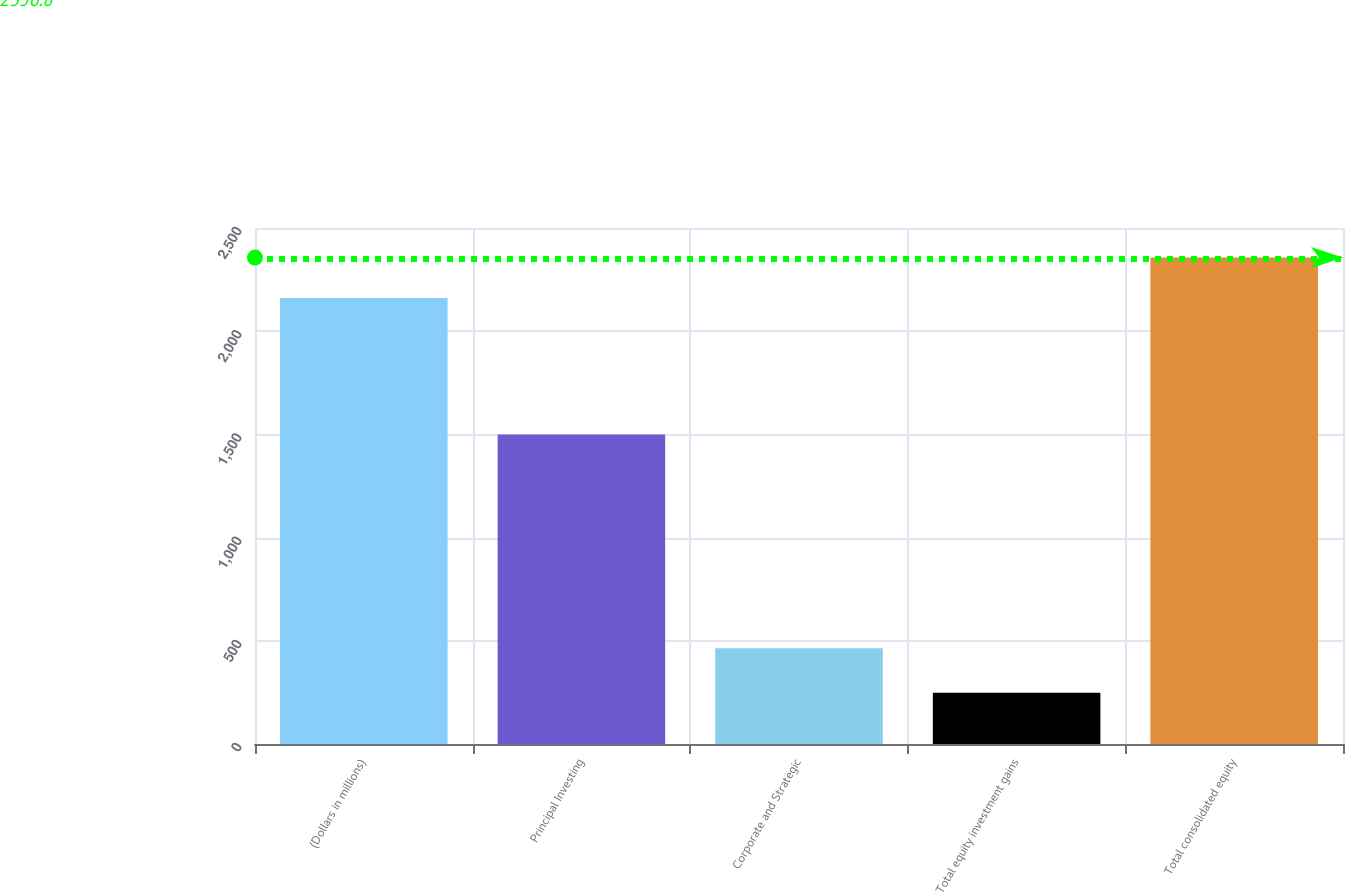Convert chart. <chart><loc_0><loc_0><loc_500><loc_500><bar_chart><fcel>(Dollars in millions)<fcel>Principal Investing<fcel>Corporate and Strategic<fcel>Total equity investment gains<fcel>Total consolidated equity<nl><fcel>2160.4<fcel>1500<fcel>464<fcel>248<fcel>2356.8<nl></chart> 